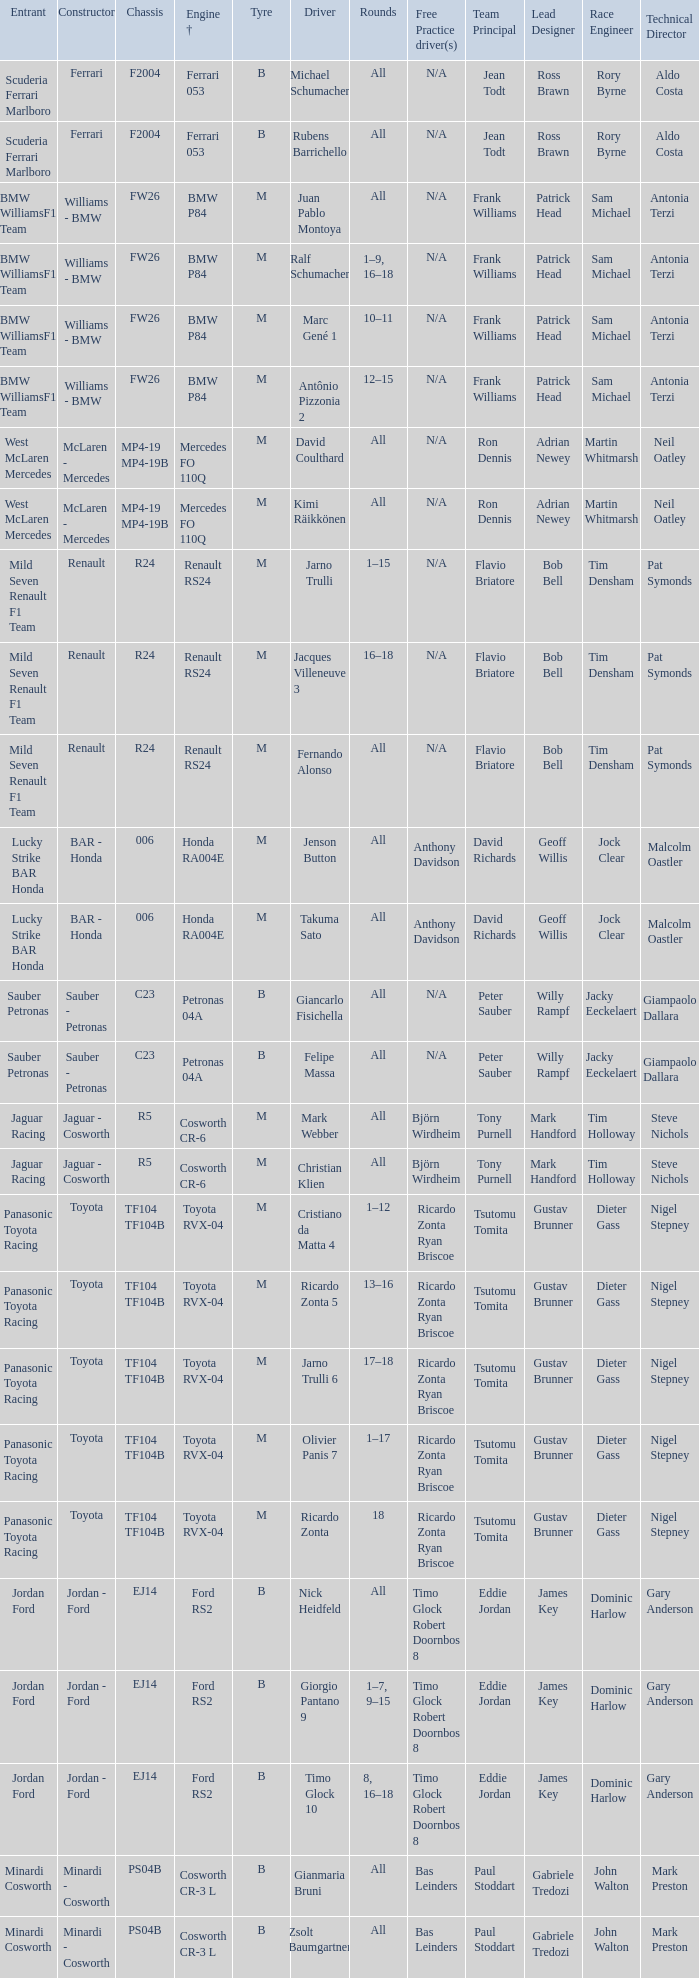What kind of chassis does Ricardo Zonta have? TF104 TF104B. 